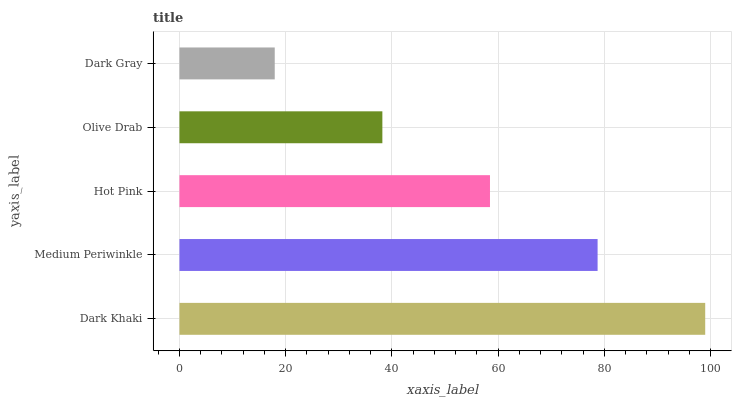Is Dark Gray the minimum?
Answer yes or no. Yes. Is Dark Khaki the maximum?
Answer yes or no. Yes. Is Medium Periwinkle the minimum?
Answer yes or no. No. Is Medium Periwinkle the maximum?
Answer yes or no. No. Is Dark Khaki greater than Medium Periwinkle?
Answer yes or no. Yes. Is Medium Periwinkle less than Dark Khaki?
Answer yes or no. Yes. Is Medium Periwinkle greater than Dark Khaki?
Answer yes or no. No. Is Dark Khaki less than Medium Periwinkle?
Answer yes or no. No. Is Hot Pink the high median?
Answer yes or no. Yes. Is Hot Pink the low median?
Answer yes or no. Yes. Is Dark Gray the high median?
Answer yes or no. No. Is Dark Khaki the low median?
Answer yes or no. No. 